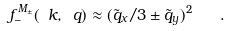Convert formula to latex. <formula><loc_0><loc_0><loc_500><loc_500>f _ { - } ^ { M _ { \pm } } ( \ k , \ q ) \approx ( \tilde { q } _ { x } / 3 \pm \tilde { q } _ { y } ) ^ { 2 } \quad .</formula> 